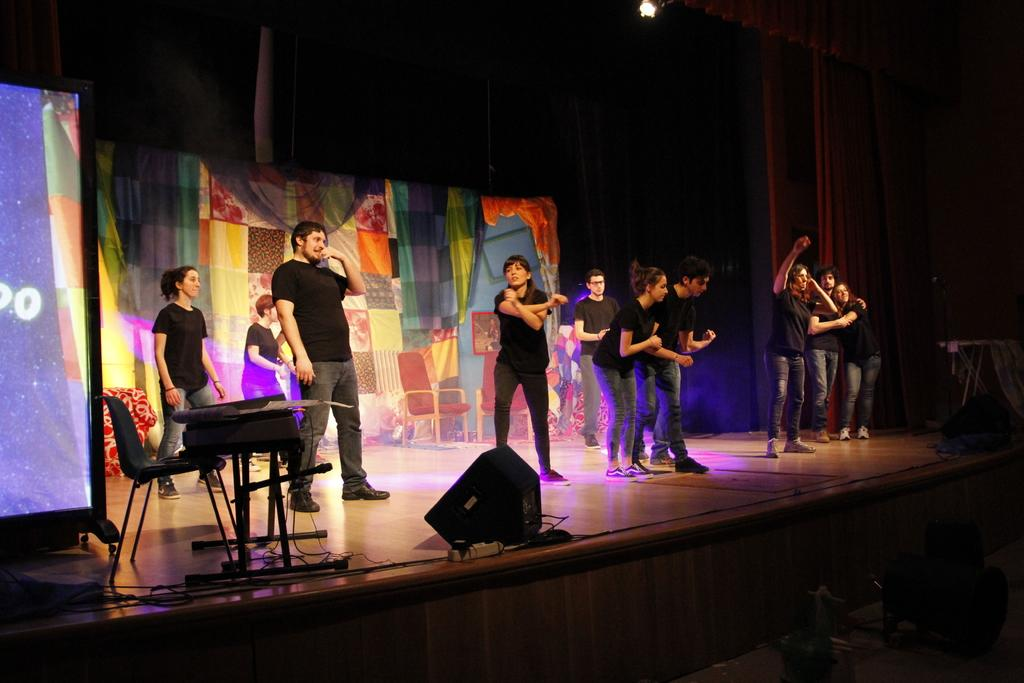What is the main feature in the foreground of the image? There is a stage in the foreground of the image. What can be seen on the stage? A: There are persons standing on the stage, lights, a table, a chair, and a screen curtain. Is there any lighting equipment visible on the stage? Yes, there are lights visible on the stage. What is the condition of the background in the image? The background of the image is dark. Can you describe the top of the stage? There is a light on the top of the stage. Can you see any wilderness or ants in the image? No, there is no wilderness or ants present in the image; it features a stage with various elements and a dark background. Is there a kitten playing with the screen curtain on the stage? There is no kitten present in the image; it only features a stage with various elements and a dark background. 